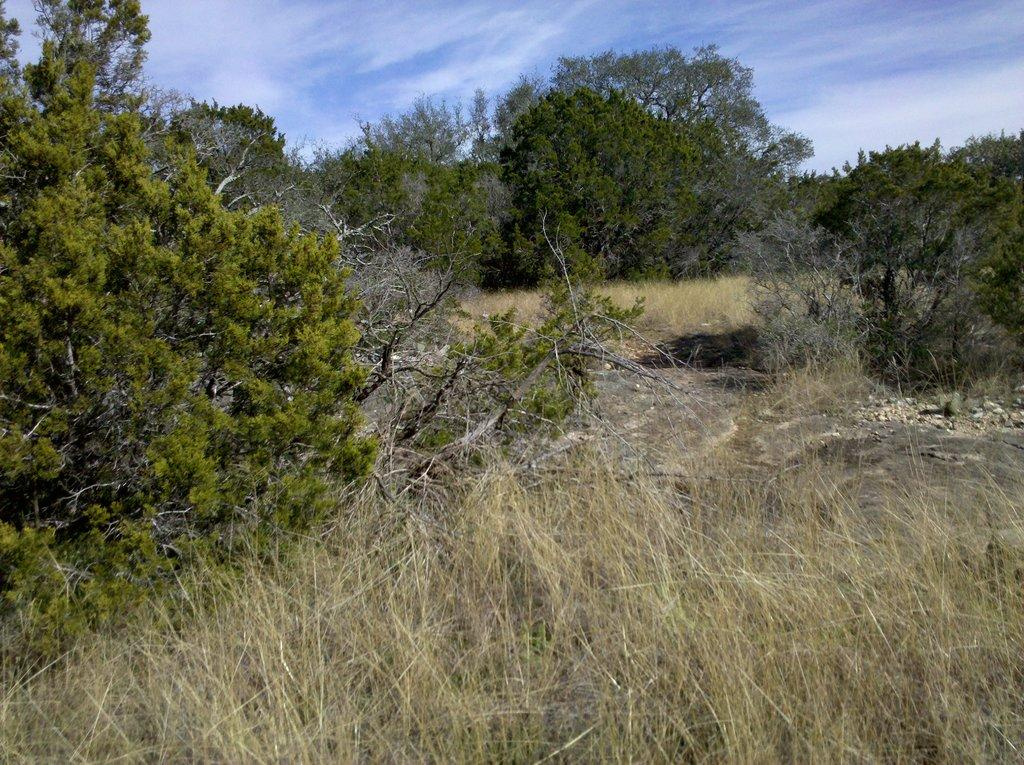What type of environment might the image be taken from? The image might be taken from a forest. What types of vegetation can be seen in the image? There are trees and plants in the image. Can you describe the background of the image? There are trees in the background of the image. What is visible at the bottom of the image? There is grass visible at the bottom of the image. How many iron sculptures can be seen in the image? There are no iron sculptures present in the image. What type of geese are grazing on the grass in the image? There are no geese present in the image; only trees, plants, and grass can be seen. 